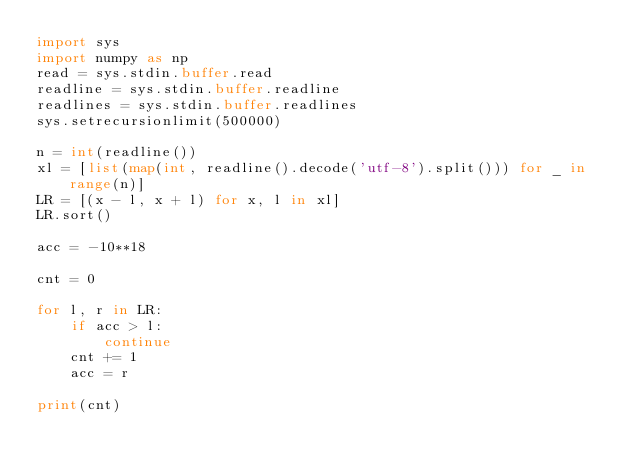<code> <loc_0><loc_0><loc_500><loc_500><_Python_>import sys
import numpy as np
read = sys.stdin.buffer.read
readline = sys.stdin.buffer.readline
readlines = sys.stdin.buffer.readlines
sys.setrecursionlimit(500000)

n = int(readline())
xl = [list(map(int, readline().decode('utf-8').split())) for _ in range(n)]
LR = [(x - l, x + l) for x, l in xl]
LR.sort()

acc = -10**18

cnt = 0

for l, r in LR:
    if acc > l:
        continue
    cnt += 1
    acc = r

print(cnt)</code> 